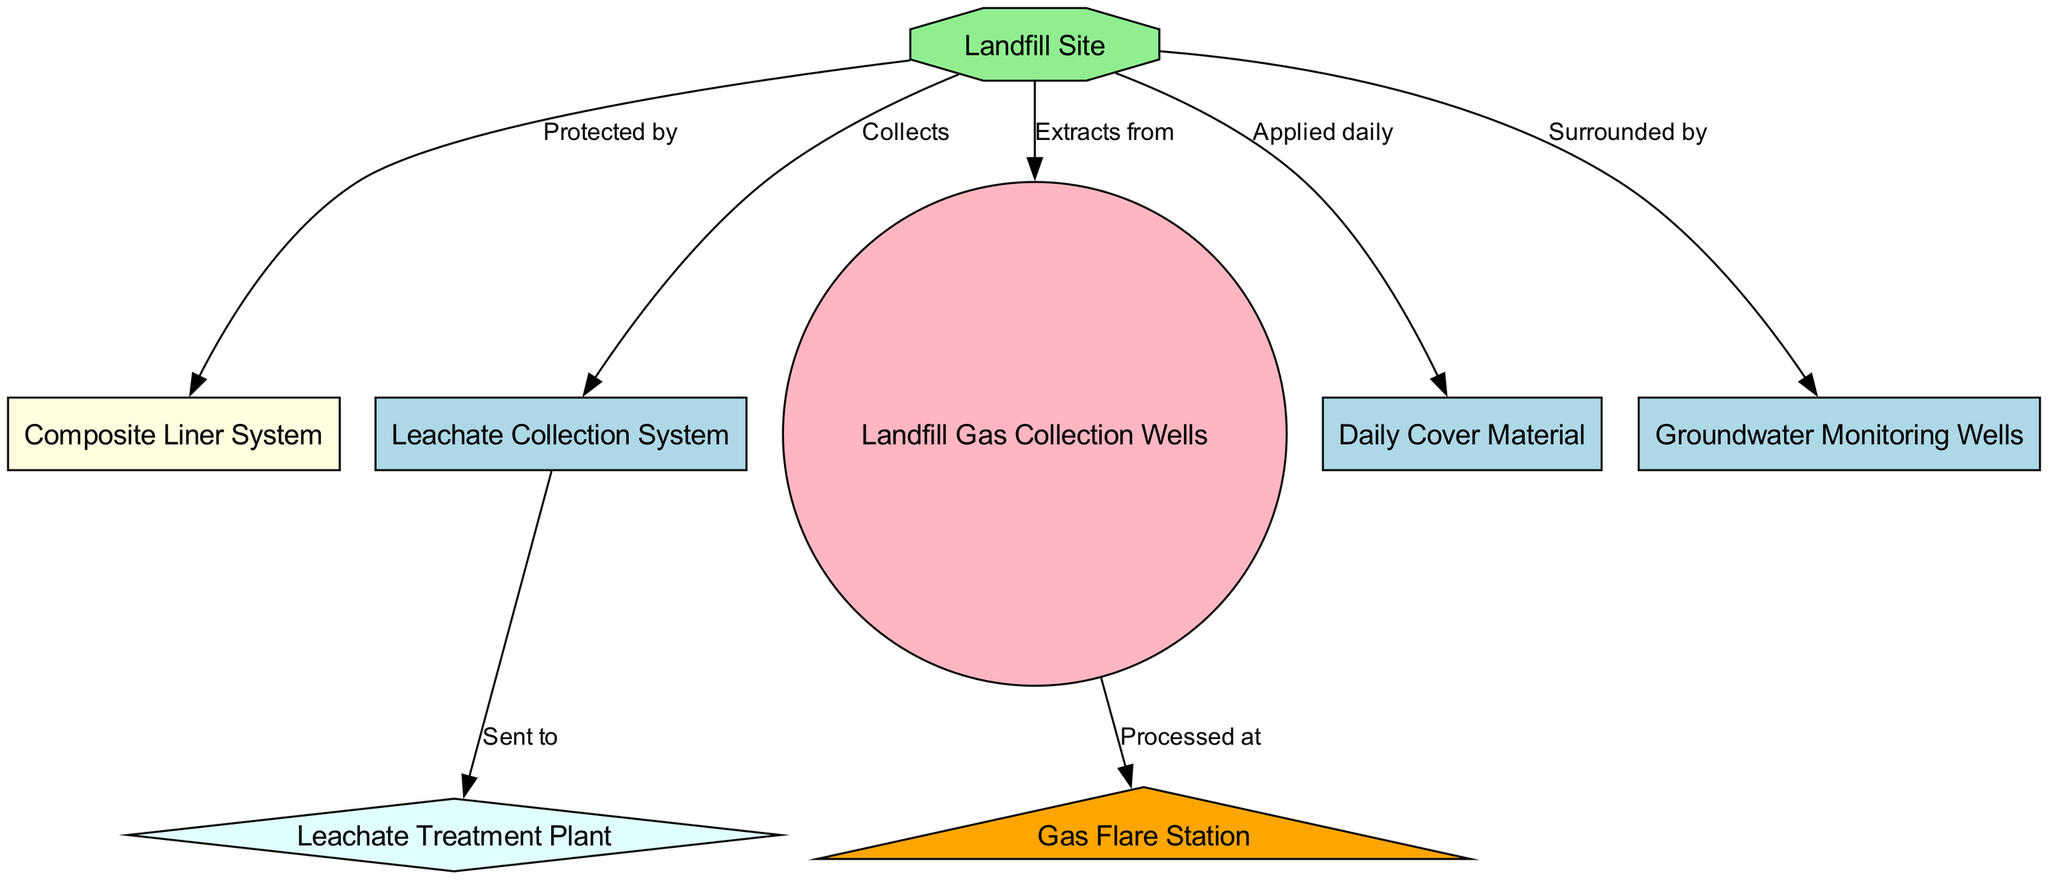What is the overall shape of the landfill node? The landfill node is shaped as an octagon, which is distinctive compared to other rectangular or circular nodes in the diagram. This shape is specifically intended to highlight its significance.
Answer: octagon How many nodes are depicted in the diagram? The diagram contains a total of eight nodes. By counting each labeled item, we identify the nodes for the landfill site, liner system, leachate system, gas collection wells, flare station, daily cover material, groundwater monitoring wells, and leachate treatment plant.
Answer: eight What does the leachate collection system do? The leachate collection system collects leachate from the landfill site. This relationship is directly indicated by the label on the edge connecting these two nodes.
Answer: collects Which system processes the landfill gas? The gas flare station processes the landfill gas, according to the directed edge that points from the gas collection wells to the flare station, indicating a flow of gas for processing.
Answer: flare station What is applied daily on the landfill? The daily cover material is what is applied each day on the landfill site for environmental protection and odor control, as stated on the edge that connects these two nodes.
Answer: daily cover material What is sent to the leachate treatment plant? Leachate is sent to the leachate treatment plant, as directly indicated by the edge connecting the leachate collection system to the treatment plant, indicating the flow of leachate for treatment.
Answer: leachate Which system surrounds the landfill? The groundwater monitoring wells surround the landfill, as clarified by the relationship shown in the diagram connecting the monitoring wells to the landfill site.
Answer: groundwater monitoring wells How is the landfill protected? The landfill is protected by a composite liner system, as denoted by the edge that starts from the landfill node and points towards the liner node, indicating a protective measure in place.
Answer: composite liner system In what direction does leachate flow towards? Leachate flows towards the leachate treatment plant, as represented by the directed edge indicating the movement from the leachate collection system to the treatment facility.
Answer: leachate treatment plant 